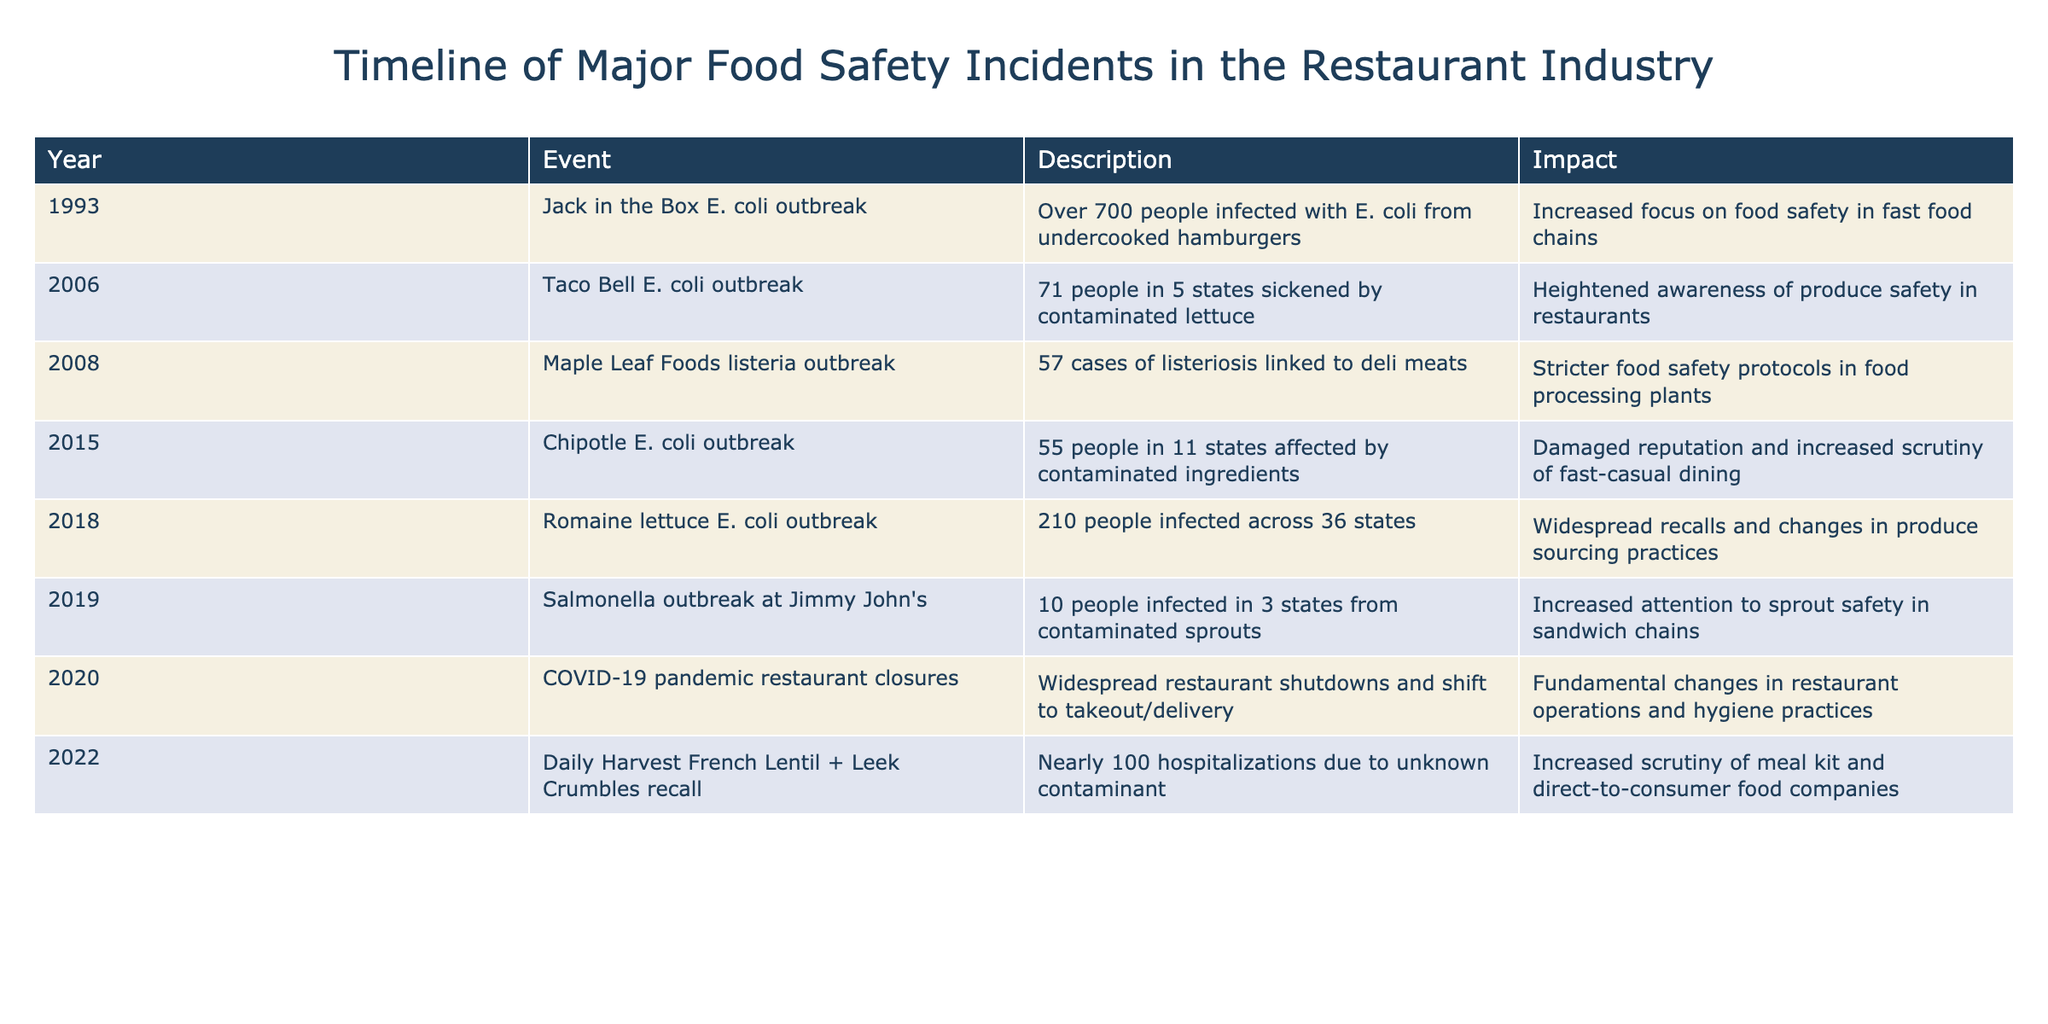What type of outbreak was associated with Chipotle in 2015? The table specifically mentions that the event in 2015 is a "Chipotle E. coli outbreak." This indicates that the type of outbreak is related to E. coli.
Answer: E. coli How many people were infected in the 2018 Romaine lettuce E. coli outbreak? According to the table, 210 people were infected in the 2018 Romaine lettuce E. coli outbreak.
Answer: 210 Which food safety incident had the highest impact on food processing plants? The Maple Leaf Foods listeria outbreak in 2008 had an impact described as "stricter food safety protocols in food processing plants," indicating it was particularly significant for that industry.
Answer: Maple Leaf Foods listeria outbreak What was the average number of people infected in the listed outbreaks? The number of infections from the outbreaks are: 700, 71, 57, 55, 210, 10, and 100. Adding these gives a total of 1,203 infections across 7 outbreaks. Dividing 1,203 by 7 results in an average of approximately 171.86.
Answer: Approximately 171.86 Was the Taco Bell E. coli outbreak associated with contaminated produce? Yes, the table states that Taco Bell had 71 people sickened by contaminated lettuce, confirming that the outbreak was related to contaminated produce.
Answer: Yes How many major food safety incidents occurred in the year 2019? The table lists a single event for 2019: the Salmonella outbreak at Jimmy John's, indicating that only one incident is recorded for that year.
Answer: 1 In which incident did nearly 100 hospitalizations occur, and what year was it? The incident that had nearly 100 hospitalizations was the Daily Harvest French Lentil + Leek Crumbles recall in 2022, as specified in the description for that event.
Answer: Daily Harvest French Lentil + Leek Crumbles recall, 2022 What was the consequence of the COVID-19 pandemic on restaurant operations? The table indicates that the COVID-19 pandemic resulted in widespread restaurant shutdowns and a shift to takeout and delivery, leading to fundamental changes in restaurant operations.
Answer: Fundamental changes in operations How many states were affected by the Chipotle E. coli outbreak? The Chipotle E. coli outbreak affected 11 states, as mentioned in the event description of that incident.
Answer: 11 